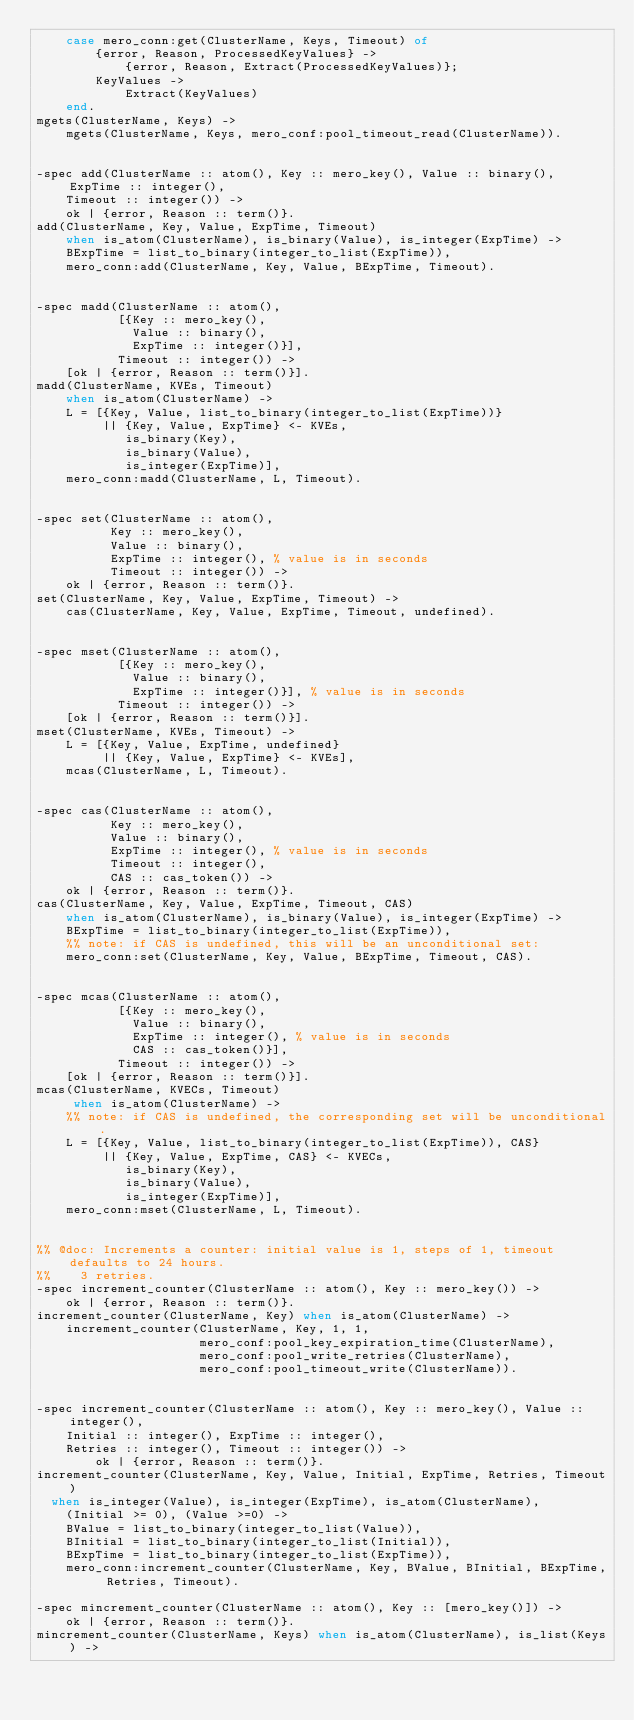<code> <loc_0><loc_0><loc_500><loc_500><_Erlang_>    case mero_conn:get(ClusterName, Keys, Timeout) of
        {error, Reason, ProcessedKeyValues} ->
            {error, Reason, Extract(ProcessedKeyValues)};
        KeyValues ->
            Extract(KeyValues)
    end.
mgets(ClusterName, Keys) ->
    mgets(ClusterName, Keys, mero_conf:pool_timeout_read(ClusterName)).


-spec add(ClusterName :: atom(), Key :: mero_key(), Value :: binary(), ExpTime :: integer(),
    Timeout :: integer()) ->
    ok | {error, Reason :: term()}.
add(ClusterName, Key, Value, ExpTime, Timeout)
    when is_atom(ClusterName), is_binary(Value), is_integer(ExpTime) ->
    BExpTime = list_to_binary(integer_to_list(ExpTime)),
    mero_conn:add(ClusterName, Key, Value, BExpTime, Timeout).


-spec madd(ClusterName :: atom(),
           [{Key :: mero_key(),
             Value :: binary(),
             ExpTime :: integer()}],
           Timeout :: integer()) ->
    [ok | {error, Reason :: term()}].
madd(ClusterName, KVEs, Timeout)
    when is_atom(ClusterName) ->
    L = [{Key, Value, list_to_binary(integer_to_list(ExpTime))}
         || {Key, Value, ExpTime} <- KVEs,
            is_binary(Key),
            is_binary(Value),
            is_integer(ExpTime)],
    mero_conn:madd(ClusterName, L, Timeout).


-spec set(ClusterName :: atom(),
          Key :: mero_key(),
          Value :: binary(),
          ExpTime :: integer(), % value is in seconds
          Timeout :: integer()) ->
    ok | {error, Reason :: term()}.
set(ClusterName, Key, Value, ExpTime, Timeout) ->
    cas(ClusterName, Key, Value, ExpTime, Timeout, undefined).


-spec mset(ClusterName :: atom(),
           [{Key :: mero_key(),
             Value :: binary(),
             ExpTime :: integer()}], % value is in seconds
           Timeout :: integer()) ->
    [ok | {error, Reason :: term()}].
mset(ClusterName, KVEs, Timeout) ->
    L = [{Key, Value, ExpTime, undefined}
         || {Key, Value, ExpTime} <- KVEs],
    mcas(ClusterName, L, Timeout).


-spec cas(ClusterName :: atom(),
          Key :: mero_key(),
          Value :: binary(),
          ExpTime :: integer(), % value is in seconds
          Timeout :: integer(),
          CAS :: cas_token()) ->
    ok | {error, Reason :: term()}.
cas(ClusterName, Key, Value, ExpTime, Timeout, CAS)
    when is_atom(ClusterName), is_binary(Value), is_integer(ExpTime) ->
    BExpTime = list_to_binary(integer_to_list(ExpTime)),
    %% note: if CAS is undefined, this will be an unconditional set:
    mero_conn:set(ClusterName, Key, Value, BExpTime, Timeout, CAS).


-spec mcas(ClusterName :: atom(),
           [{Key :: mero_key(),
             Value :: binary(),
             ExpTime :: integer(), % value is in seconds
             CAS :: cas_token()}],
           Timeout :: integer()) ->
    [ok | {error, Reason :: term()}].
mcas(ClusterName, KVECs, Timeout)
     when is_atom(ClusterName) ->
    %% note: if CAS is undefined, the corresponding set will be unconditional.
    L = [{Key, Value, list_to_binary(integer_to_list(ExpTime)), CAS}
         || {Key, Value, ExpTime, CAS} <- KVECs,
            is_binary(Key),
            is_binary(Value),
            is_integer(ExpTime)],
    mero_conn:mset(ClusterName, L, Timeout).


%% @doc: Increments a counter: initial value is 1, steps of 1, timeout defaults to 24 hours.
%%    3 retries.
-spec increment_counter(ClusterName :: atom(), Key :: mero_key()) ->
    ok | {error, Reason :: term()}.
increment_counter(ClusterName, Key) when is_atom(ClusterName) ->
    increment_counter(ClusterName, Key, 1, 1,
                      mero_conf:pool_key_expiration_time(ClusterName),
                      mero_conf:pool_write_retries(ClusterName),
                      mero_conf:pool_timeout_write(ClusterName)).


-spec increment_counter(ClusterName :: atom(), Key :: mero_key(), Value :: integer(),
    Initial :: integer(), ExpTime :: integer(),
    Retries :: integer(), Timeout :: integer()) ->
        ok | {error, Reason :: term()}.
increment_counter(ClusterName, Key, Value, Initial, ExpTime, Retries, Timeout)
  when is_integer(Value), is_integer(ExpTime), is_atom(ClusterName),
    (Initial >= 0), (Value >=0) ->
    BValue = list_to_binary(integer_to_list(Value)),
    BInitial = list_to_binary(integer_to_list(Initial)),
    BExpTime = list_to_binary(integer_to_list(ExpTime)),
    mero_conn:increment_counter(ClusterName, Key, BValue, BInitial, BExpTime, Retries, Timeout).

-spec mincrement_counter(ClusterName :: atom(), Key :: [mero_key()]) ->
    ok | {error, Reason :: term()}.
mincrement_counter(ClusterName, Keys) when is_atom(ClusterName), is_list(Keys) -></code> 